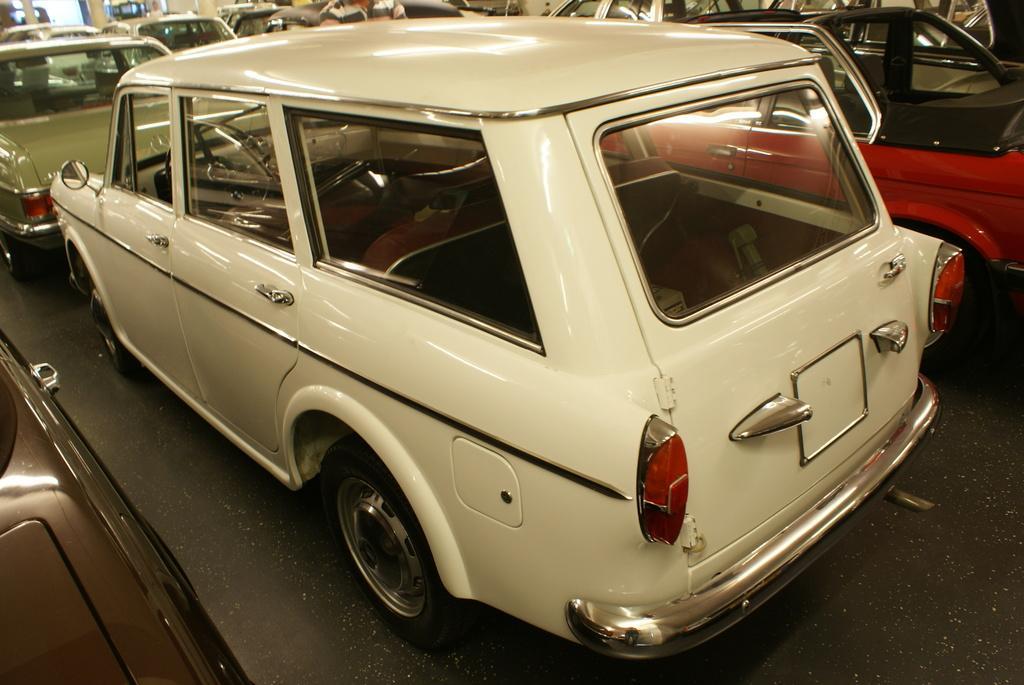Please provide a concise description of this image. In the picture it looks like a car showroom there are a lot of cars displayed in the showroom every car is of different model and different color. 